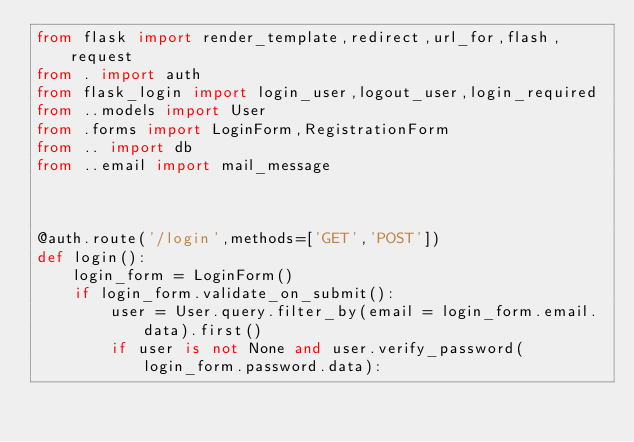<code> <loc_0><loc_0><loc_500><loc_500><_Python_>from flask import render_template,redirect,url_for,flash,request
from . import auth
from flask_login import login_user,logout_user,login_required
from ..models import User
from .forms import LoginForm,RegistrationForm
from .. import db
from ..email import mail_message



@auth.route('/login',methods=['GET','POST'])
def login():
    login_form = LoginForm()
    if login_form.validate_on_submit():
        user = User.query.filter_by(email = login_form.email.data).first()
        if user is not None and user.verify_password(login_form.password.data):</code> 